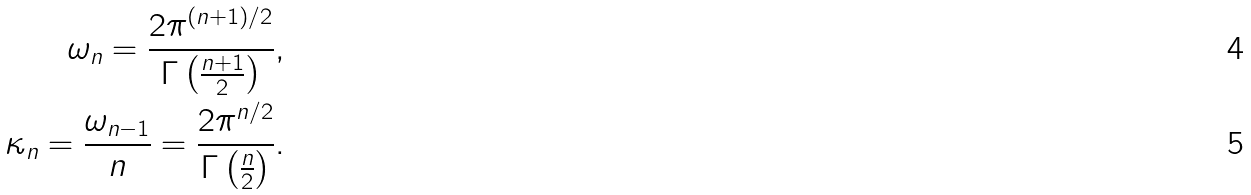Convert formula to latex. <formula><loc_0><loc_0><loc_500><loc_500>\omega _ { n } = \frac { 2 \pi ^ { ( n + 1 ) / 2 } } { \Gamma \left ( \frac { n + 1 } 2 \right ) } , \\ \kappa _ { n } = \frac { \omega _ { n - 1 } } { n } = \frac { 2 \pi ^ { n / 2 } } { \Gamma \left ( \frac { n } 2 \right ) } .</formula> 